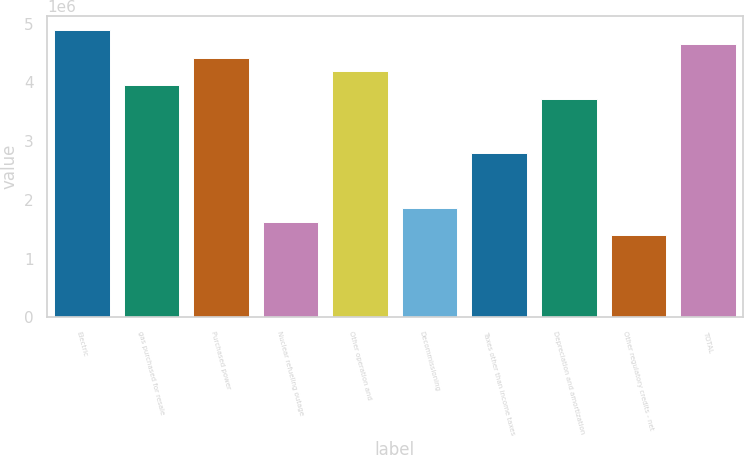Convert chart. <chart><loc_0><loc_0><loc_500><loc_500><bar_chart><fcel>Electric<fcel>gas purchased for resale<fcel>Purchased power<fcel>Nuclear refueling outage<fcel>Other operation and<fcel>Decommissioning<fcel>Taxes other than income taxes<fcel>Depreciation and amortization<fcel>Other regulatory credits - net<fcel>TOTAL<nl><fcel>4.88589e+06<fcel>3.95588e+06<fcel>4.42088e+06<fcel>1.63084e+06<fcel>4.18838e+06<fcel>1.86334e+06<fcel>2.79336e+06<fcel>3.72337e+06<fcel>1.39833e+06<fcel>4.65339e+06<nl></chart> 